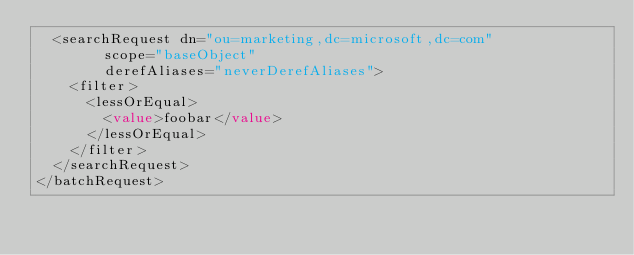Convert code to text. <code><loc_0><loc_0><loc_500><loc_500><_XML_>  <searchRequest dn="ou=marketing,dc=microsoft,dc=com"
        scope="baseObject"
        derefAliases="neverDerefAliases">
    <filter>
      <lessOrEqual>
        <value>foobar</value>
      </lessOrEqual>
    </filter>
  </searchRequest>
</batchRequest>
</code> 